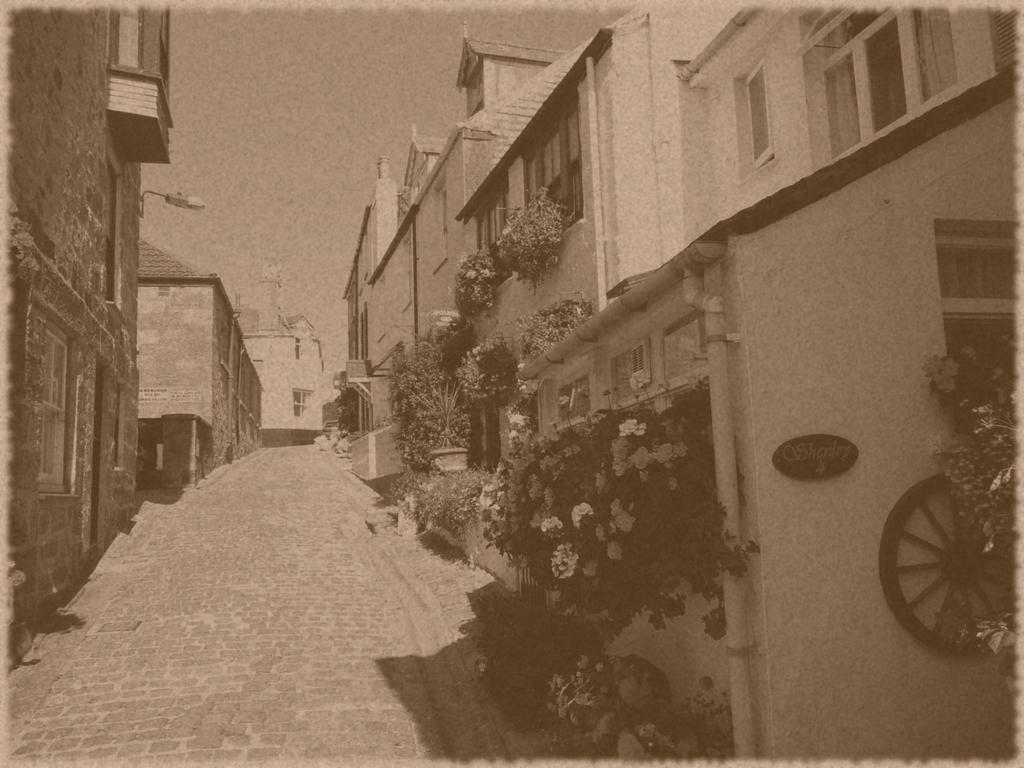Can you describe this image briefly? In the picture we can see a photograph of a path and on the both the sides we can see the houses with windows and plants near it and in the background we can see the sky. 